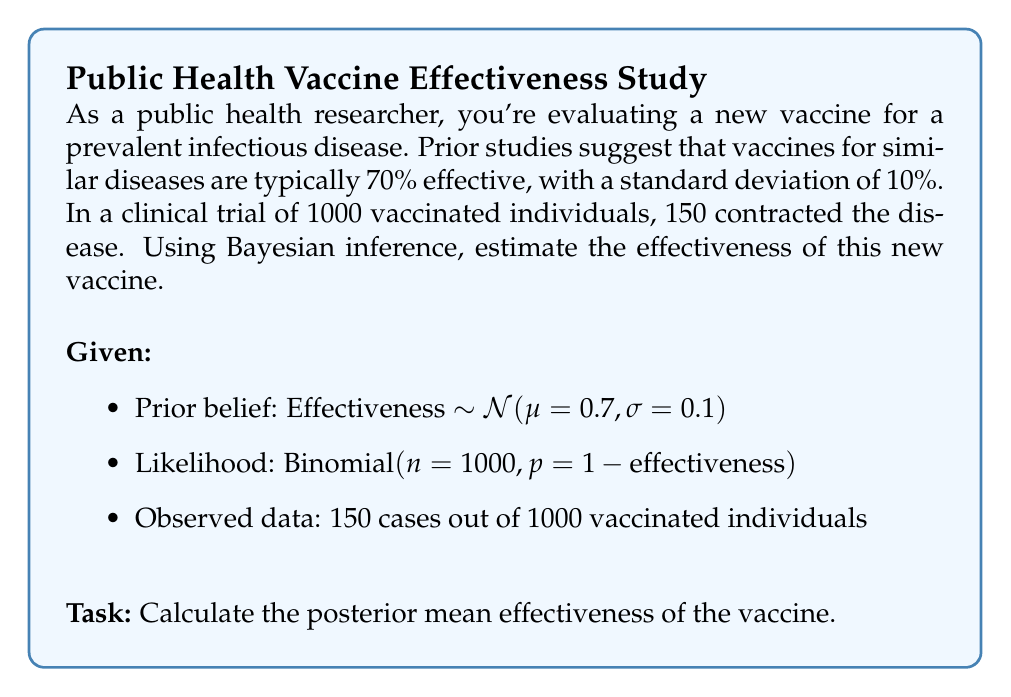Help me with this question. To solve this problem using Bayesian inference, we'll follow these steps:

1) Define the prior distribution:
   The prior is normally distributed with $\mu=0.7$ and $\sigma=0.1$.
   
2) Define the likelihood function:
   The likelihood is binomial with $n=1000$ and $p=1-\text{effectiveness}$.
   
3) Calculate the posterior distribution:
   For conjugate prior-likelihood pairs, the posterior distribution can be calculated analytically. However, in this case, we don't have a conjugate pair, so we'll use a numerical approach.

4) Use the Beta distribution as an approximation:
   We can approximate the posterior using a Beta distribution, which is conjugate to the Binomial likelihood.
   
   Prior (approximate): $\text{Beta}(a,b)$ where $a$ and $b$ are chosen to match the mean and variance of the normal prior.
   
   $\mu = \frac{a}{a+b} = 0.7$
   $\sigma^2 = \frac{ab}{(a+b)^2(a+b+1)} = 0.1^2$
   
   Solving these equations:
   $a \approx 44.1$ and $b \approx 18.9$

5) Update with the data:
   Posterior: $\text{Beta}(a + \text{successes}, b + \text{failures})$
   $= \text{Beta}(44.1 + (1000-150), 18.9 + 150)$
   $= \text{Beta}(894.1, 168.9)$

6) Calculate the posterior mean:
   $E[\text{effectiveness}] = \frac{a}{a+b} = \frac{894.1}{894.1 + 168.9} \approx 0.841$

Therefore, the posterior mean effectiveness of the vaccine is approximately 84.1%.
Answer: 84.1% 